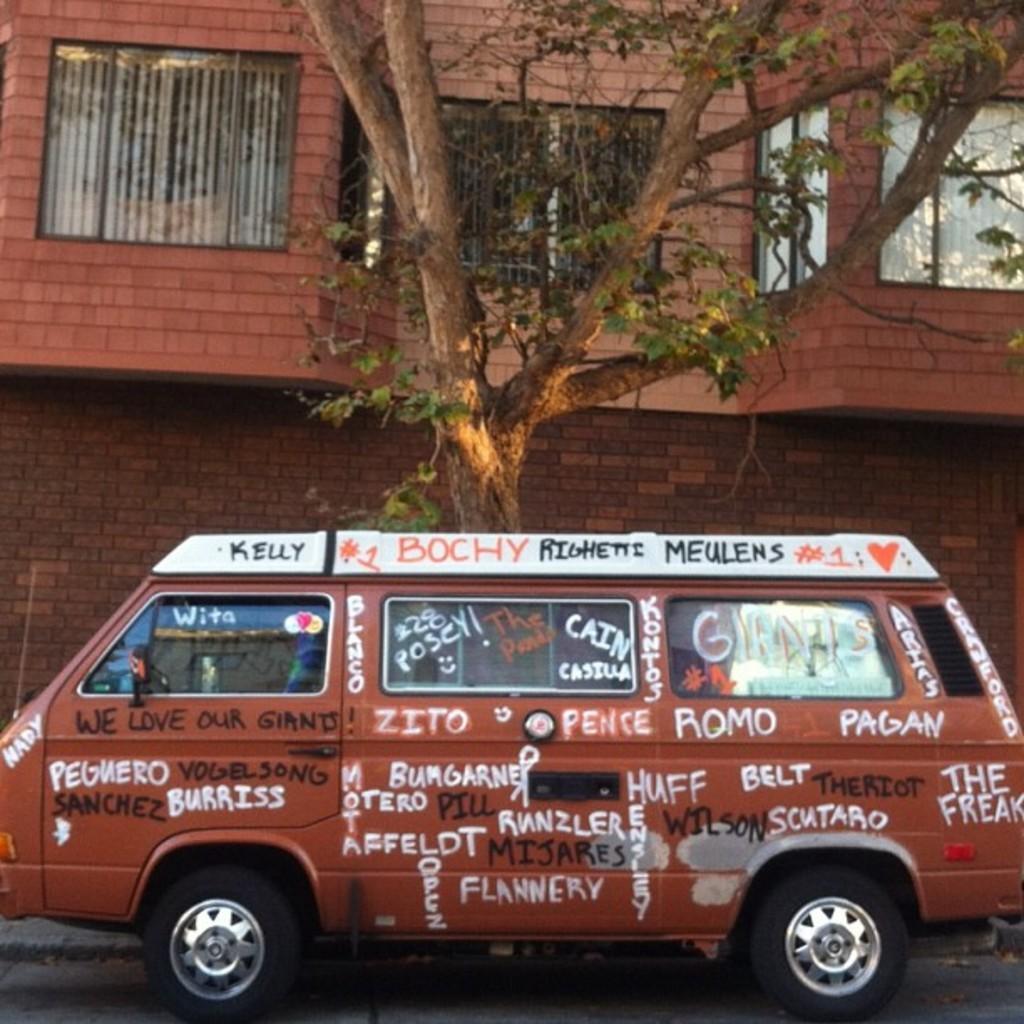In one or two sentences, can you explain what this image depicts? In this picture there is a van which is parked near to the tree. On that I can see something is written. In the back there is a building. At the top I can see the windows. 